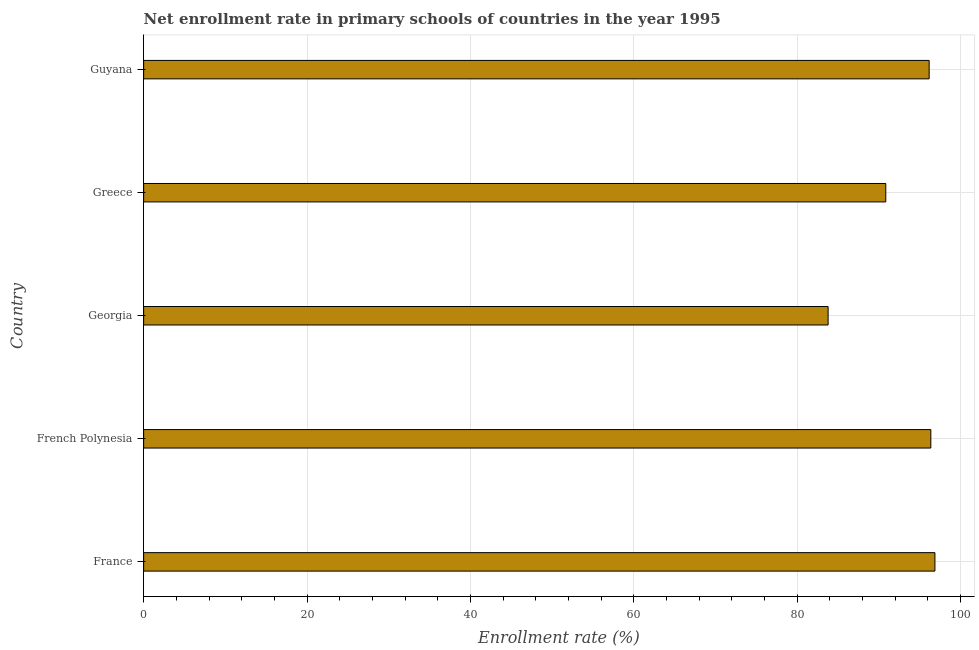What is the title of the graph?
Keep it short and to the point. Net enrollment rate in primary schools of countries in the year 1995. What is the label or title of the X-axis?
Make the answer very short. Enrollment rate (%). What is the label or title of the Y-axis?
Keep it short and to the point. Country. What is the net enrollment rate in primary schools in France?
Your response must be concise. 96.86. Across all countries, what is the maximum net enrollment rate in primary schools?
Your answer should be compact. 96.86. Across all countries, what is the minimum net enrollment rate in primary schools?
Ensure brevity in your answer.  83.78. In which country was the net enrollment rate in primary schools minimum?
Provide a succinct answer. Georgia. What is the sum of the net enrollment rate in primary schools?
Offer a terse response. 463.98. What is the difference between the net enrollment rate in primary schools in France and Guyana?
Ensure brevity in your answer.  0.71. What is the average net enrollment rate in primary schools per country?
Provide a short and direct response. 92.8. What is the median net enrollment rate in primary schools?
Give a very brief answer. 96.15. In how many countries, is the net enrollment rate in primary schools greater than 32 %?
Your response must be concise. 5. What is the ratio of the net enrollment rate in primary schools in France to that in Georgia?
Ensure brevity in your answer.  1.16. Is the net enrollment rate in primary schools in France less than that in Georgia?
Keep it short and to the point. No. What is the difference between the highest and the second highest net enrollment rate in primary schools?
Your response must be concise. 0.5. Is the sum of the net enrollment rate in primary schools in French Polynesia and Greece greater than the maximum net enrollment rate in primary schools across all countries?
Offer a terse response. Yes. What is the difference between the highest and the lowest net enrollment rate in primary schools?
Your response must be concise. 13.08. How many bars are there?
Ensure brevity in your answer.  5. How many countries are there in the graph?
Make the answer very short. 5. What is the Enrollment rate (%) in France?
Offer a very short reply. 96.86. What is the Enrollment rate (%) of French Polynesia?
Provide a short and direct response. 96.35. What is the Enrollment rate (%) in Georgia?
Offer a terse response. 83.78. What is the Enrollment rate (%) of Greece?
Offer a terse response. 90.84. What is the Enrollment rate (%) in Guyana?
Your answer should be very brief. 96.15. What is the difference between the Enrollment rate (%) in France and French Polynesia?
Your answer should be very brief. 0.5. What is the difference between the Enrollment rate (%) in France and Georgia?
Keep it short and to the point. 13.08. What is the difference between the Enrollment rate (%) in France and Greece?
Provide a succinct answer. 6.02. What is the difference between the Enrollment rate (%) in France and Guyana?
Offer a terse response. 0.71. What is the difference between the Enrollment rate (%) in French Polynesia and Georgia?
Keep it short and to the point. 12.57. What is the difference between the Enrollment rate (%) in French Polynesia and Greece?
Provide a succinct answer. 5.51. What is the difference between the Enrollment rate (%) in French Polynesia and Guyana?
Offer a terse response. 0.2. What is the difference between the Enrollment rate (%) in Georgia and Greece?
Your answer should be very brief. -7.06. What is the difference between the Enrollment rate (%) in Georgia and Guyana?
Provide a short and direct response. -12.37. What is the difference between the Enrollment rate (%) in Greece and Guyana?
Provide a succinct answer. -5.31. What is the ratio of the Enrollment rate (%) in France to that in French Polynesia?
Give a very brief answer. 1. What is the ratio of the Enrollment rate (%) in France to that in Georgia?
Your answer should be very brief. 1.16. What is the ratio of the Enrollment rate (%) in France to that in Greece?
Your answer should be compact. 1.07. What is the ratio of the Enrollment rate (%) in French Polynesia to that in Georgia?
Your answer should be compact. 1.15. What is the ratio of the Enrollment rate (%) in French Polynesia to that in Greece?
Give a very brief answer. 1.06. What is the ratio of the Enrollment rate (%) in French Polynesia to that in Guyana?
Your answer should be very brief. 1. What is the ratio of the Enrollment rate (%) in Georgia to that in Greece?
Provide a short and direct response. 0.92. What is the ratio of the Enrollment rate (%) in Georgia to that in Guyana?
Ensure brevity in your answer.  0.87. What is the ratio of the Enrollment rate (%) in Greece to that in Guyana?
Provide a short and direct response. 0.94. 